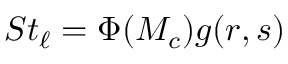<formula> <loc_0><loc_0><loc_500><loc_500>S t _ { \ell } = \Phi ( M _ { c } ) g ( r , s )</formula> 